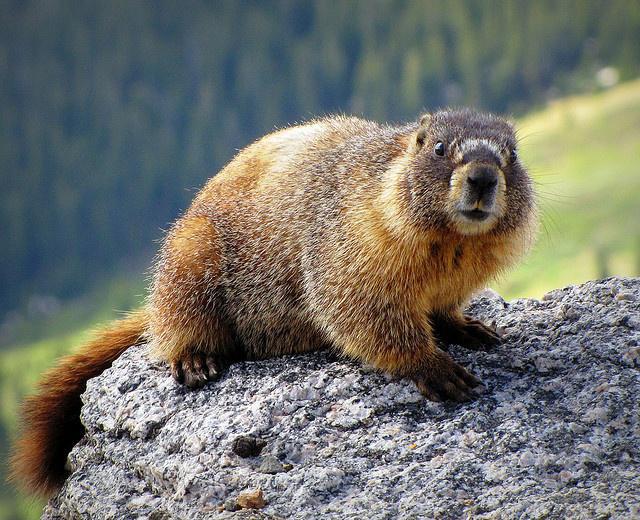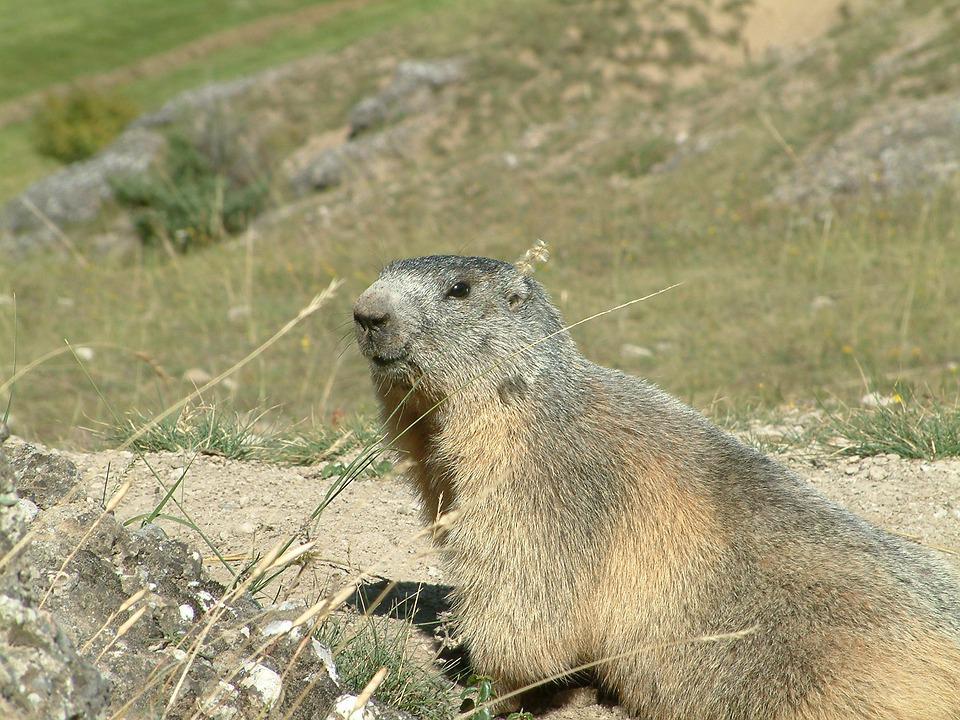The first image is the image on the left, the second image is the image on the right. Analyze the images presented: Is the assertion "There is at least one animal lying on its belly and facing left in the image on the left." valid? Answer yes or no. No. 